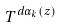<formula> <loc_0><loc_0><loc_500><loc_500>T ^ { d \alpha _ { k } ( z ) }</formula> 